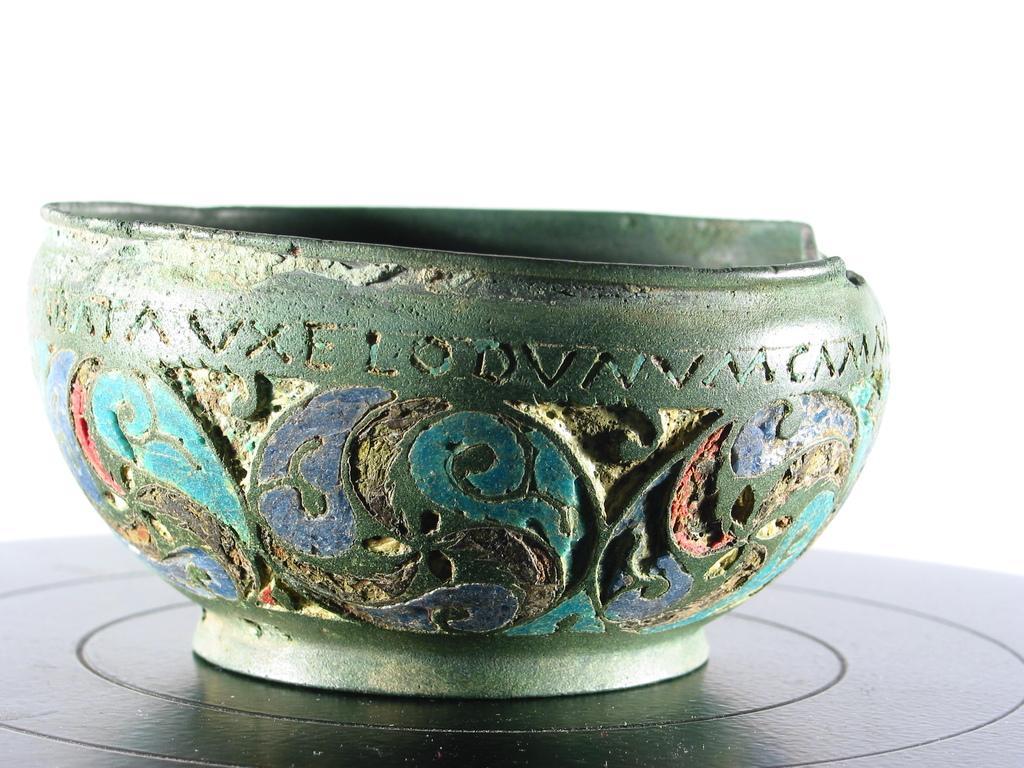Can you describe this image briefly? In this image we can see a bowl on a black surface. On the bowl we can see some text and design. The background of the image is white. 